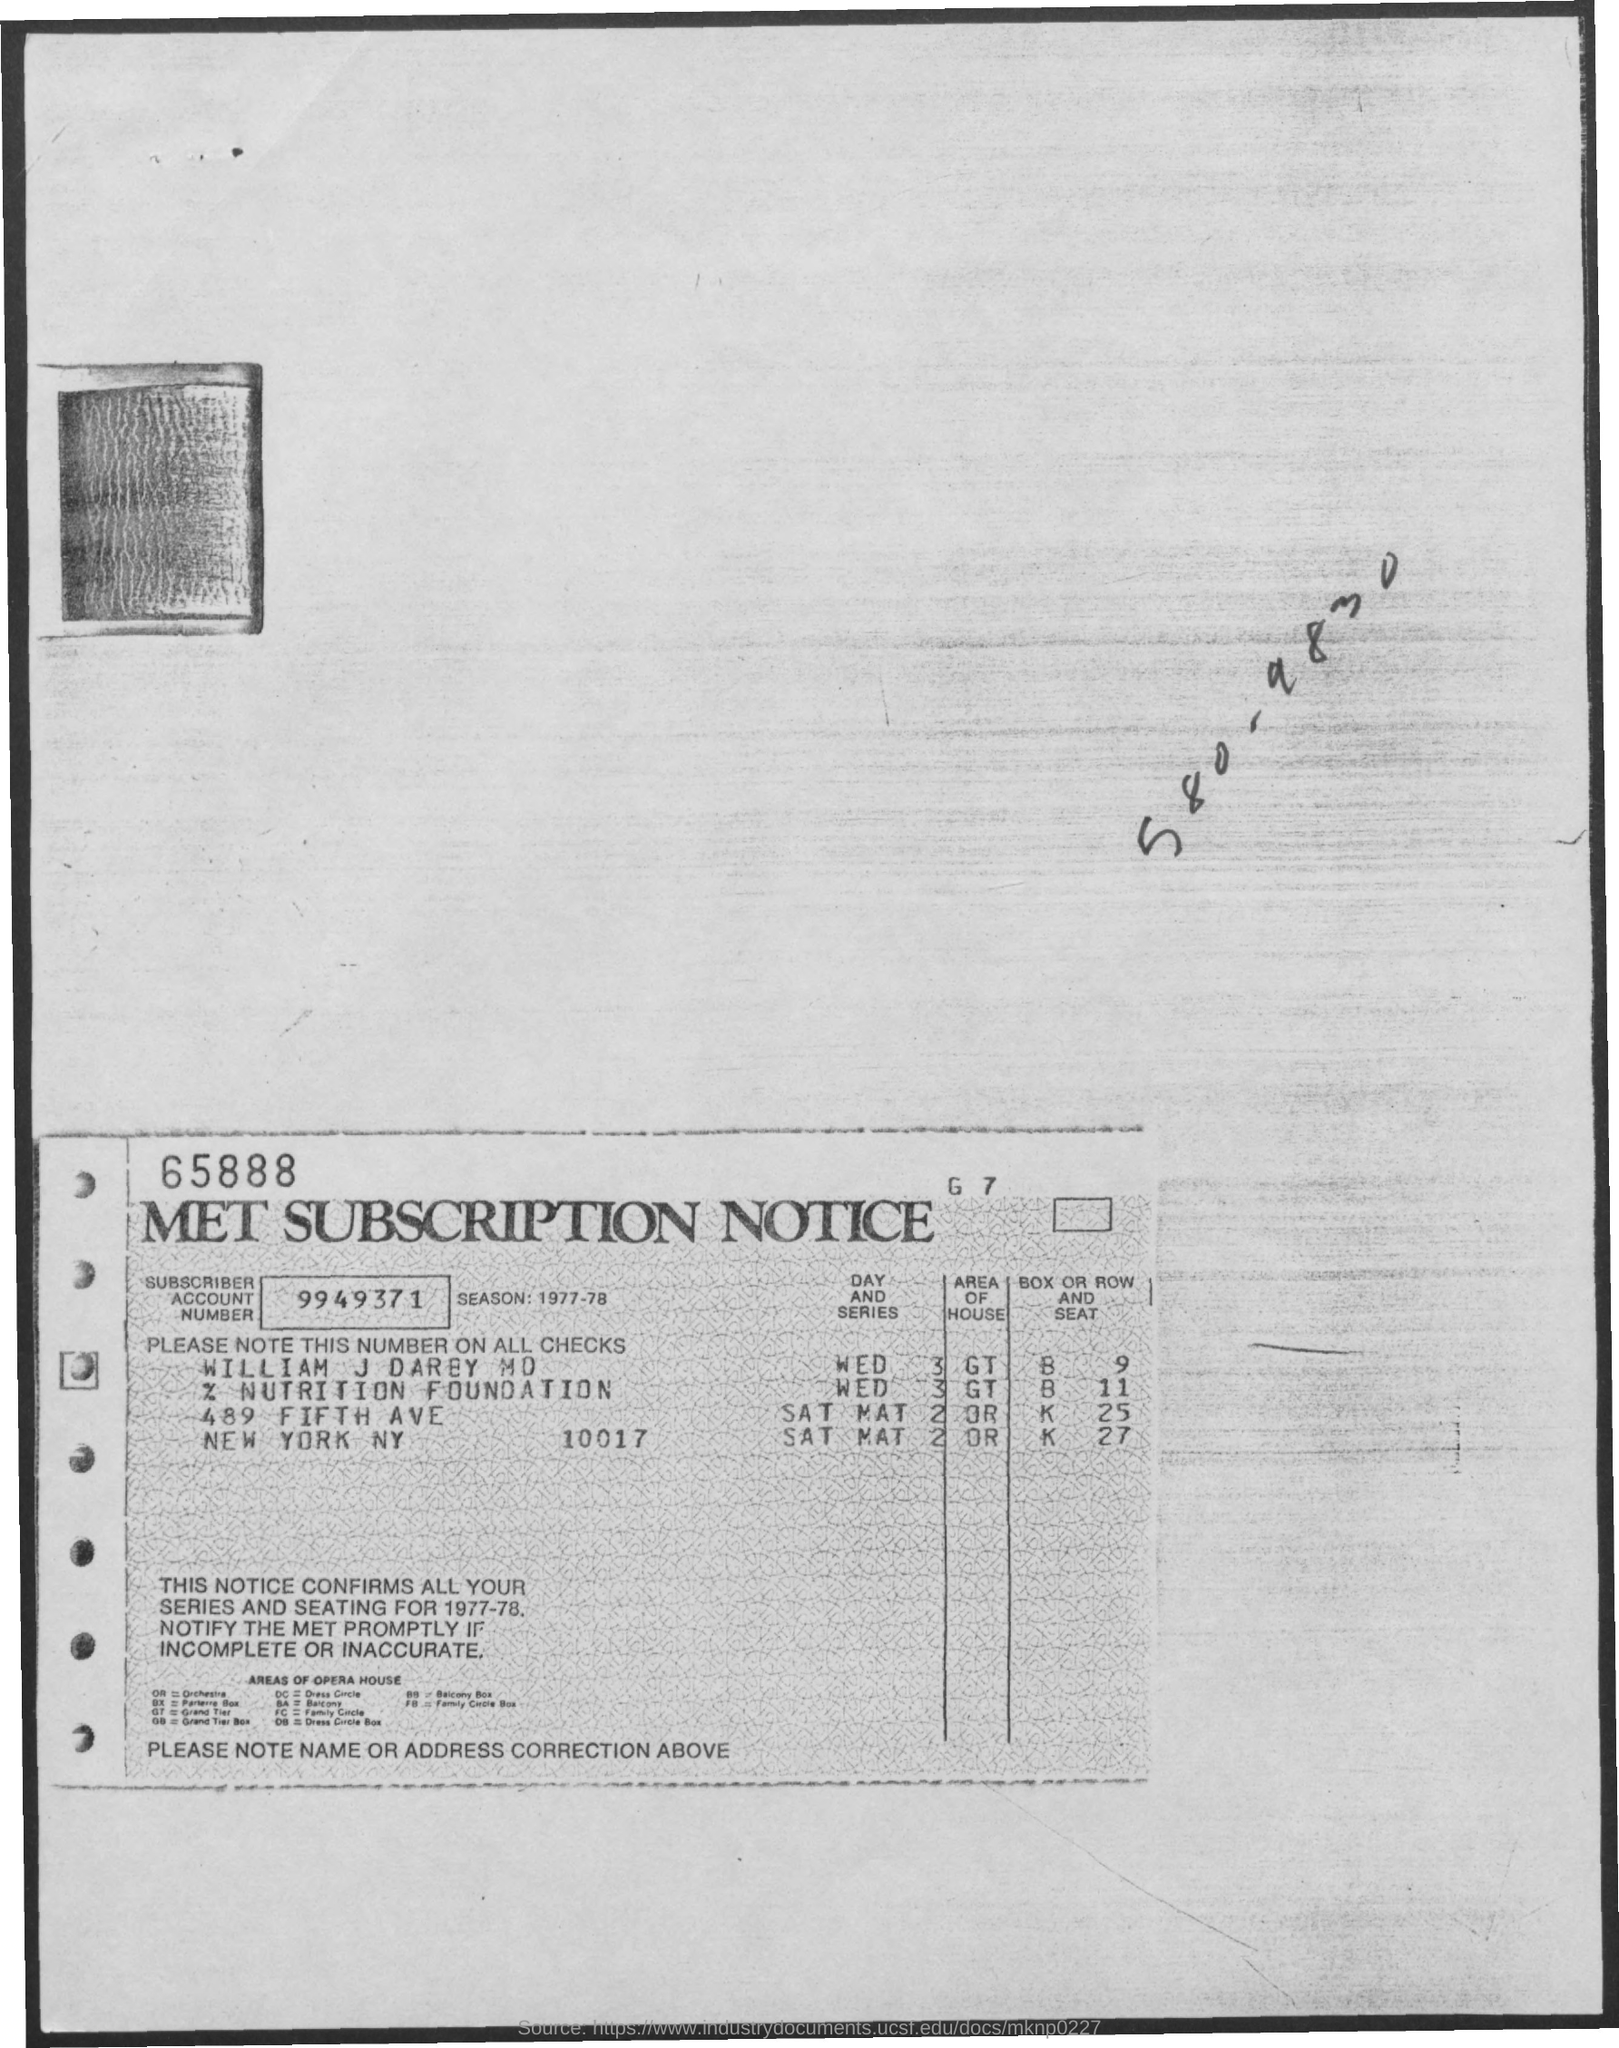Indicate a few pertinent items in this graphic. The account number is 9949371... 